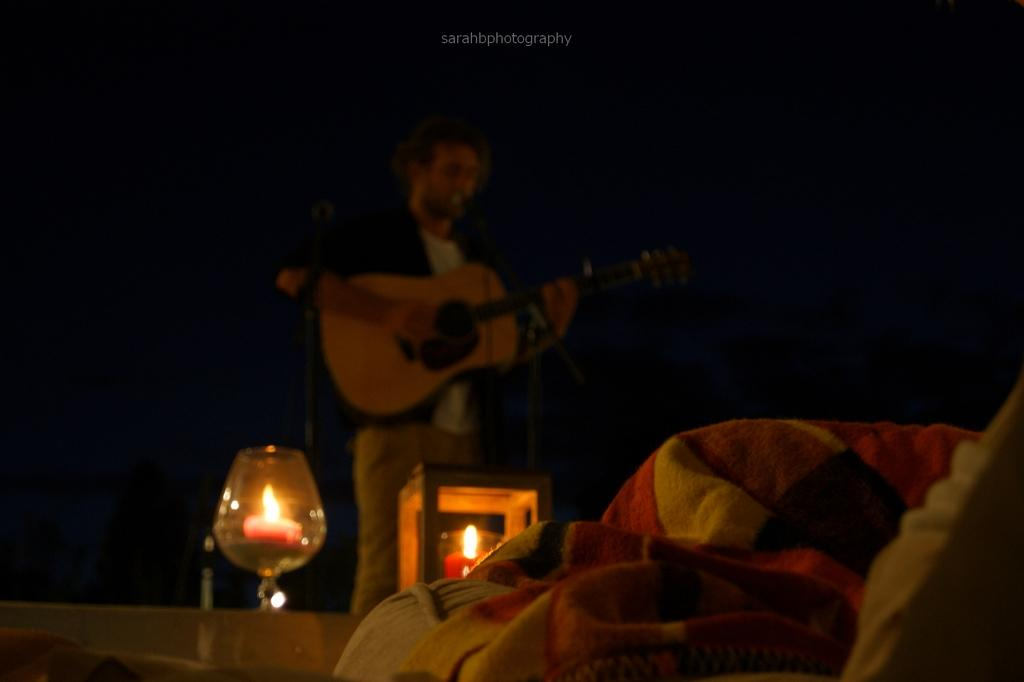What is the color of the background in the image? The background of the image is dark. Who is present in the image? There is a man in the image. What is the man doing in the image? The man is singing and playing a guitar. What objects can be seen near the man? There are candles, a glass, a blanket, and a pillow in the image. What type of skin condition does the man have in the image? There is no indication of any skin condition in the image; the man's skin is not visible. What is the man's mom doing in the image? There is no mention of the man's mom in the image; only the man and the objects around him are present. 